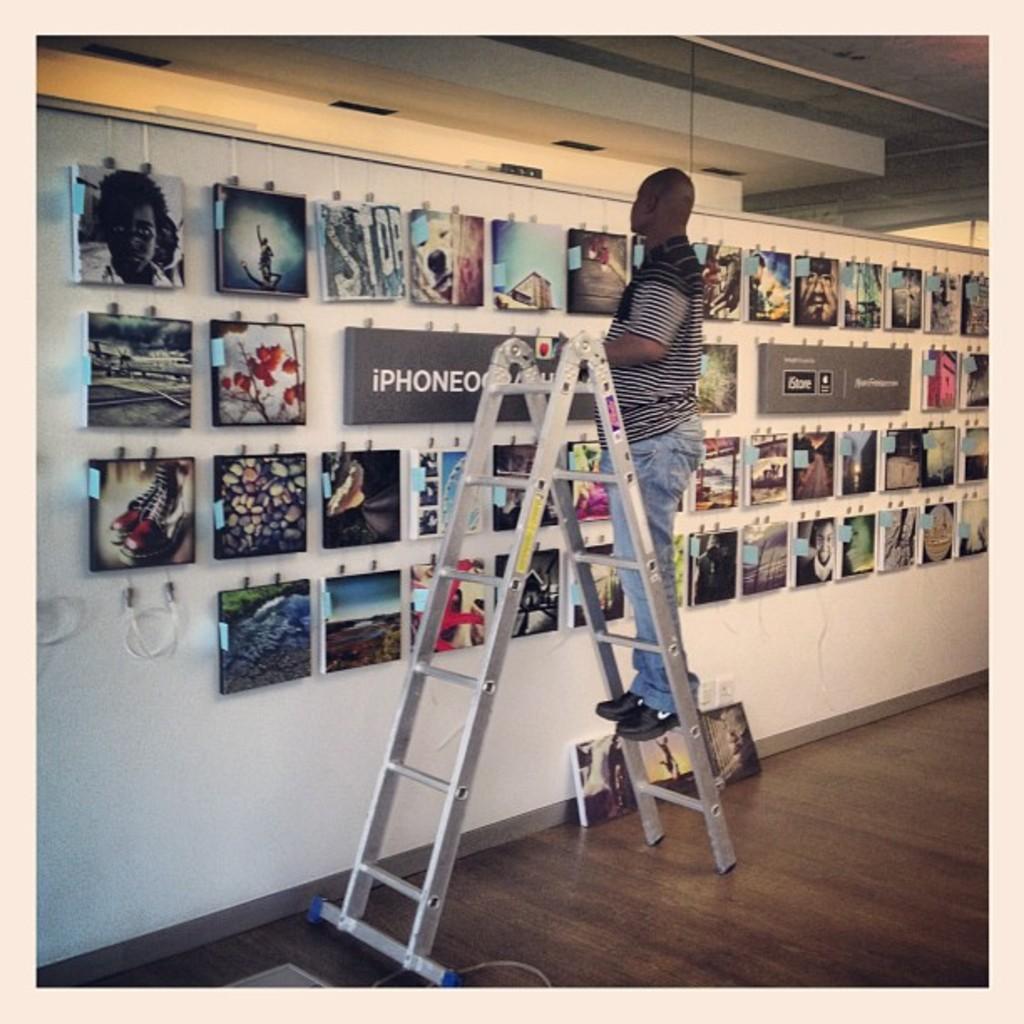What brand of phone is used for these photos?
Your answer should be very brief. Iphone. What word is painted on the 3rd piece on the top row?
Your answer should be very brief. Stop. 